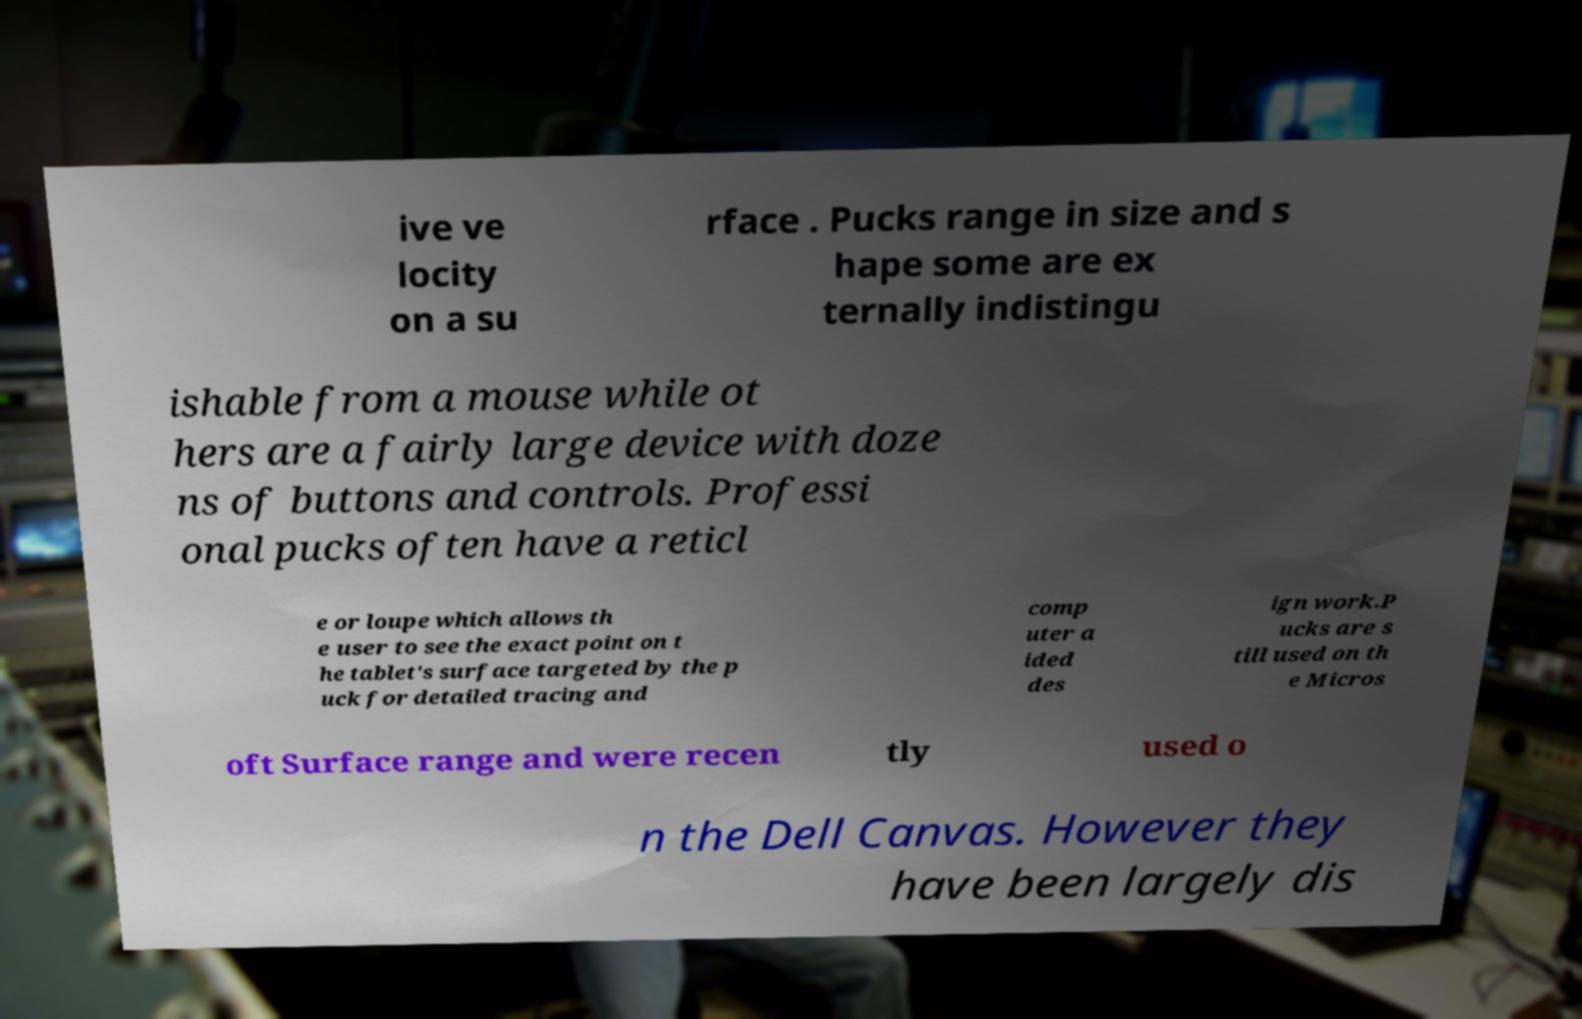Please identify and transcribe the text found in this image. ive ve locity on a su rface . Pucks range in size and s hape some are ex ternally indistingu ishable from a mouse while ot hers are a fairly large device with doze ns of buttons and controls. Professi onal pucks often have a reticl e or loupe which allows th e user to see the exact point on t he tablet's surface targeted by the p uck for detailed tracing and comp uter a ided des ign work.P ucks are s till used on th e Micros oft Surface range and were recen tly used o n the Dell Canvas. However they have been largely dis 